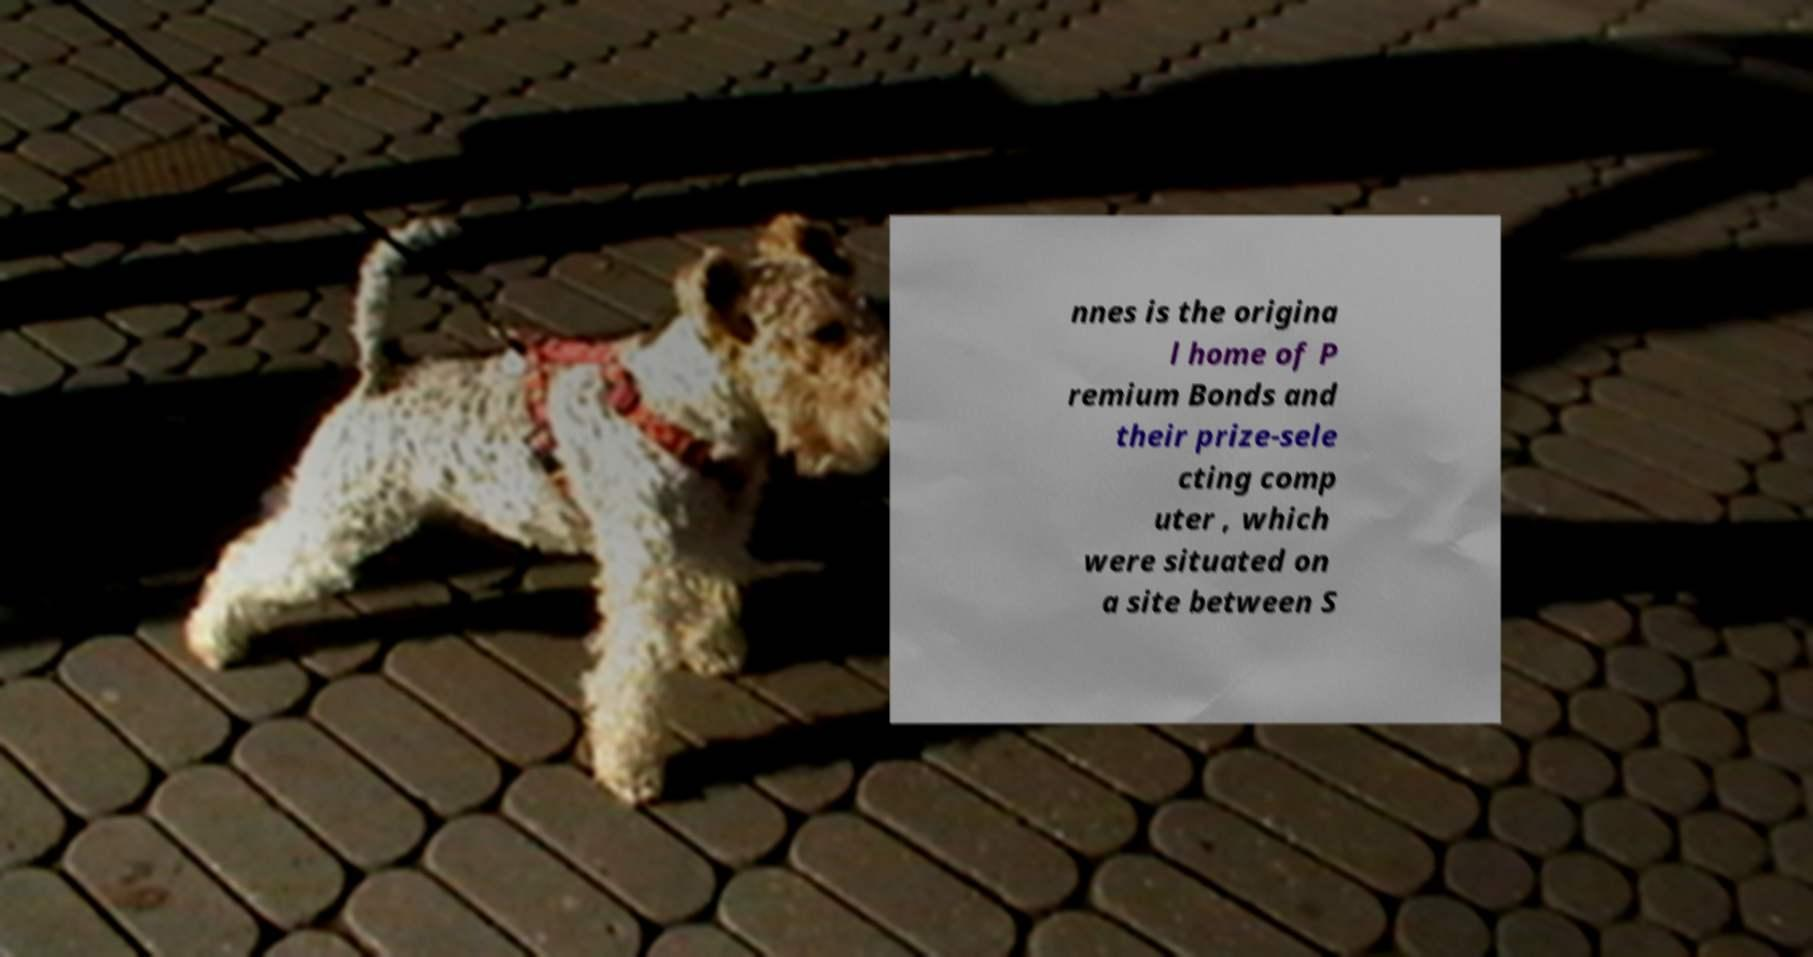Could you assist in decoding the text presented in this image and type it out clearly? nnes is the origina l home of P remium Bonds and their prize-sele cting comp uter , which were situated on a site between S 